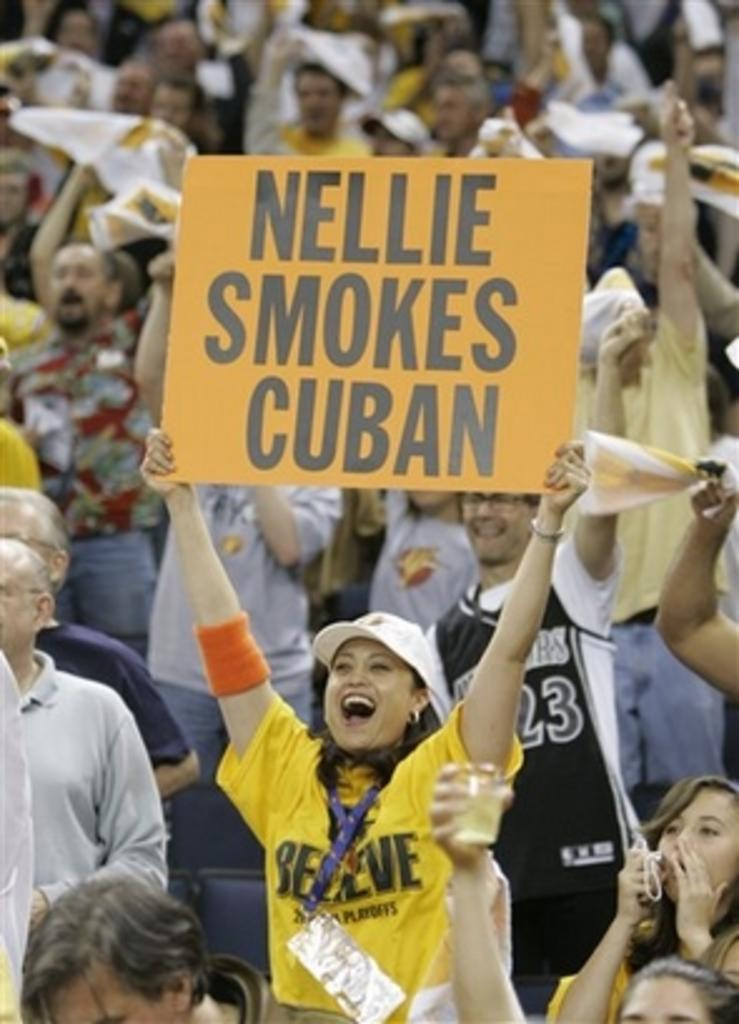Who is the main subject in the image? There is a woman in the image. What is the woman holding in the image? The woman is holding a board. What can be seen on the board that the woman is holding? There is text written on the board. Can you describe the setting or other people visible in the image? There are other people visible in the background of the image. What type of sweater is the laborer wearing in the image? There is no laborer or sweater present in the image. What type of school is depicted in the image? The image does not depict a school or any school-related activities. 